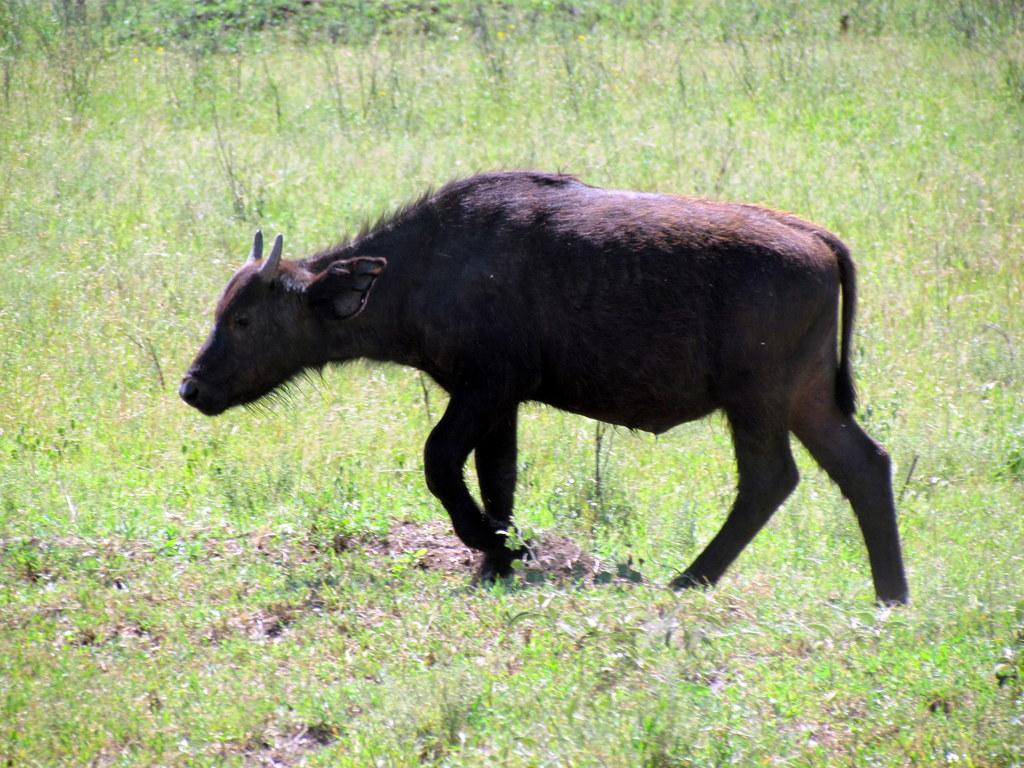What type of animal can be seen in the image? There is an animal in the image, but its specific type cannot be determined from the provided facts. What color is the animal in the image? The animal is brown in color. What is the ground made of in the image? There is green grass on the ground in the image. What other feature can be seen on the ground in the image? There is mud visible in the image. What distinguishing feature does the animal have? The animal has two horns. What color is the suggestion made by the animal in the image? There is no suggestion made by the animal in the image, and therefore no color can be attributed to it. 